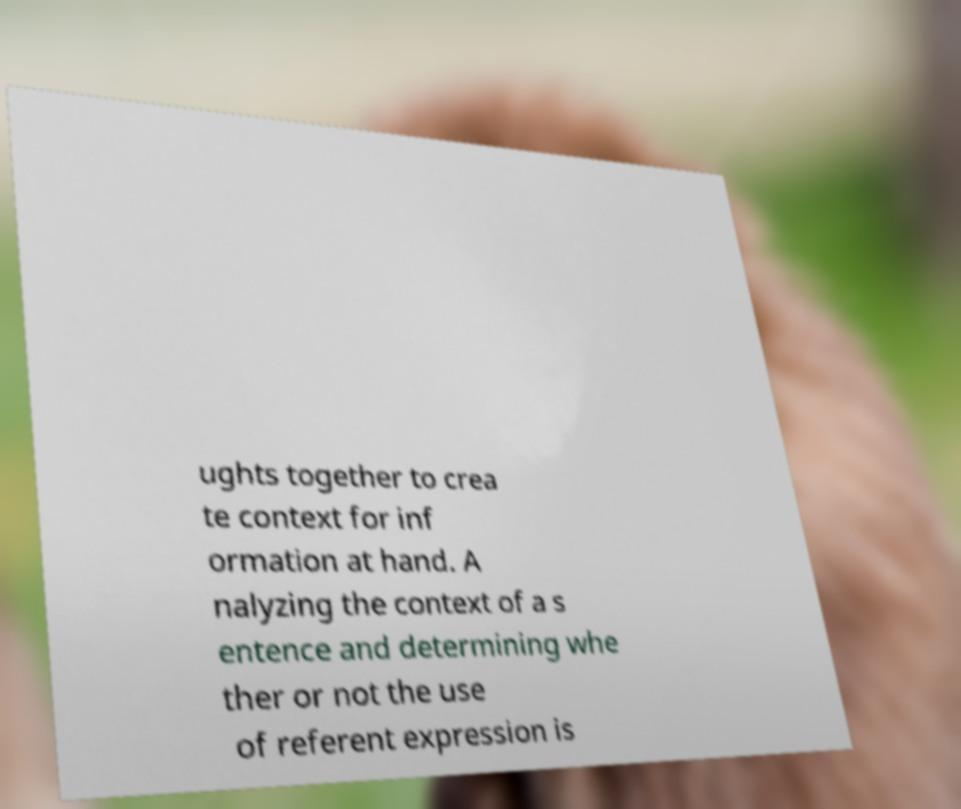For documentation purposes, I need the text within this image transcribed. Could you provide that? ughts together to crea te context for inf ormation at hand. A nalyzing the context of a s entence and determining whe ther or not the use of referent expression is 